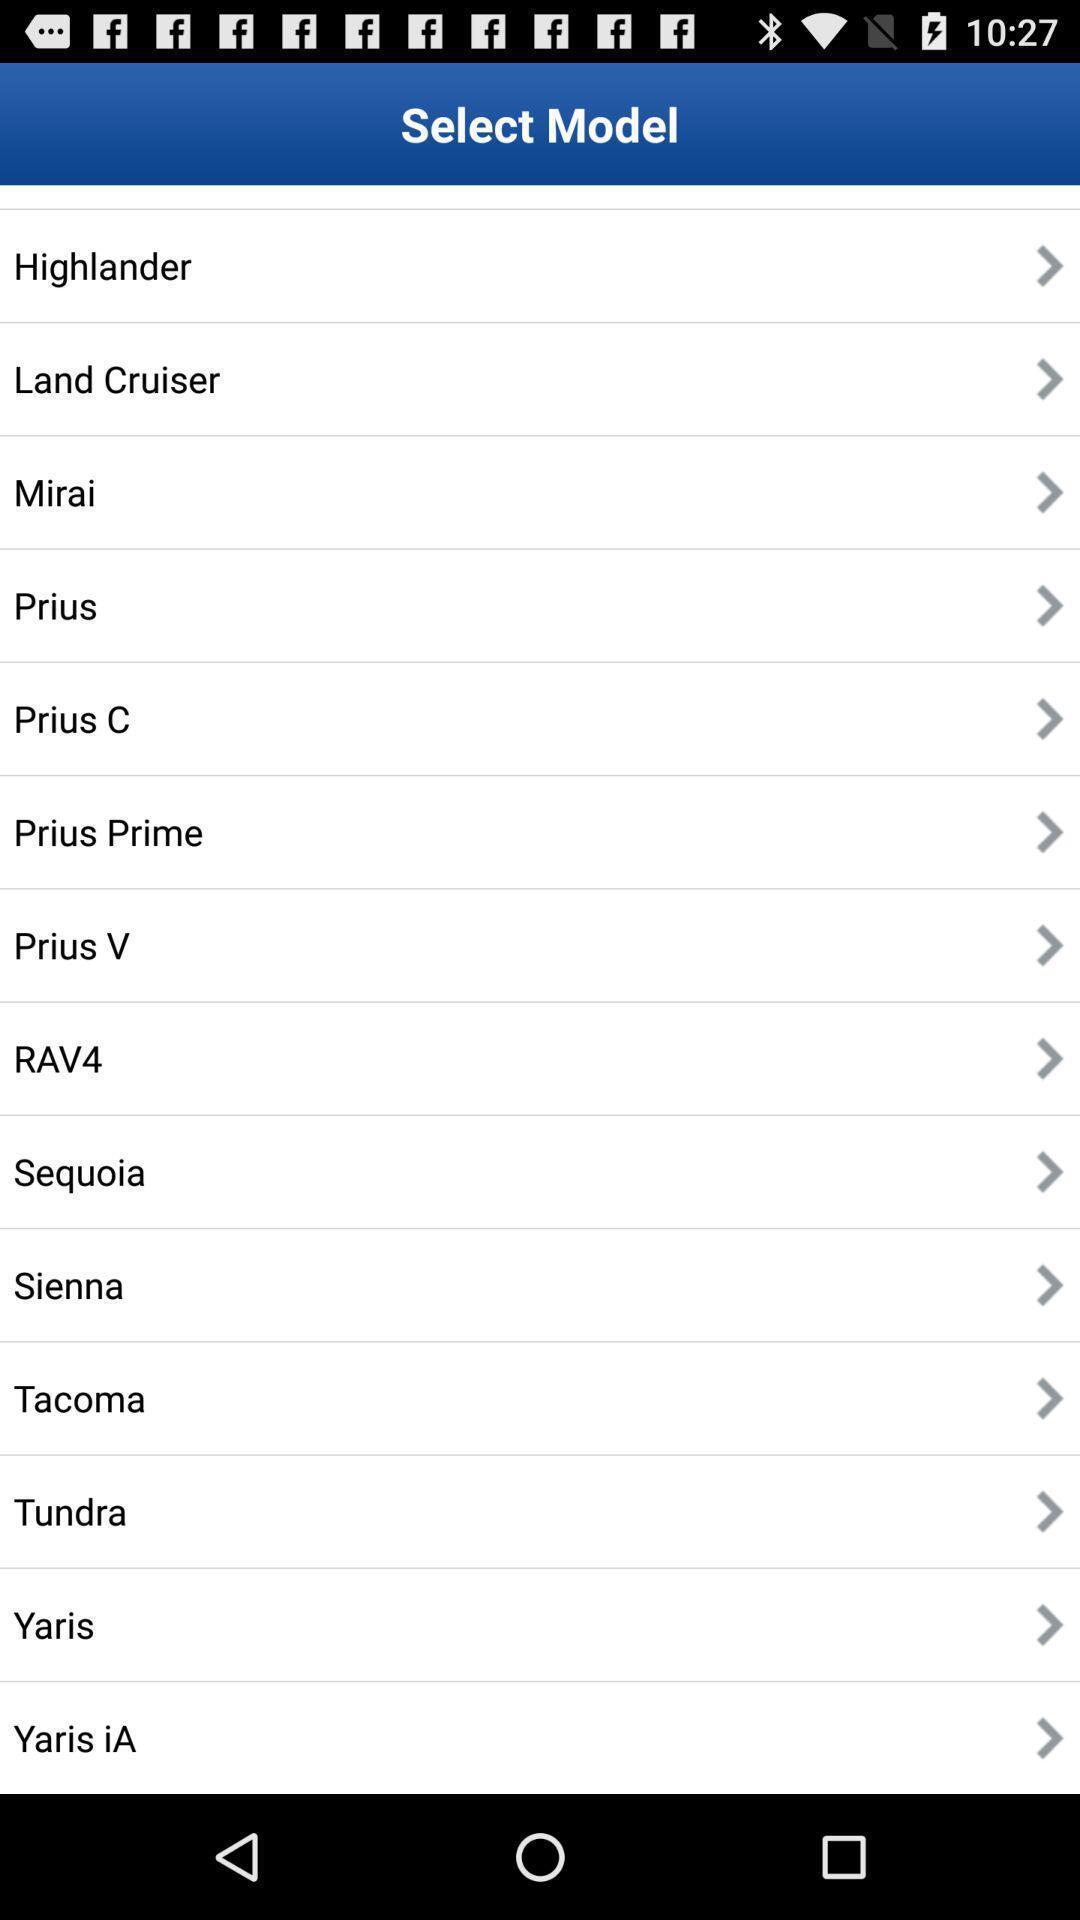Describe the key features of this screenshot. Screen displaying a list of vehicle brand names. 